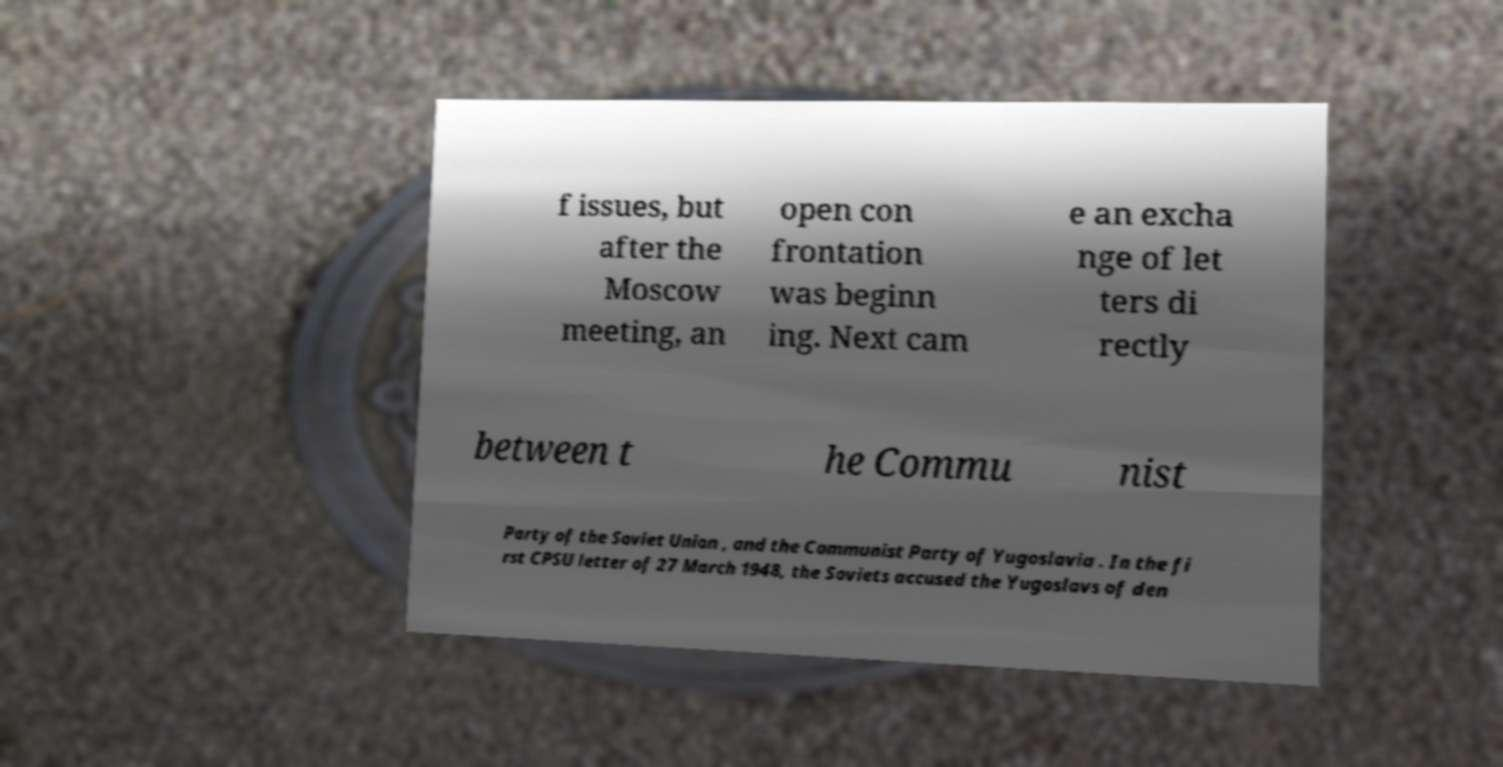I need the written content from this picture converted into text. Can you do that? f issues, but after the Moscow meeting, an open con frontation was beginn ing. Next cam e an excha nge of let ters di rectly between t he Commu nist Party of the Soviet Union , and the Communist Party of Yugoslavia . In the fi rst CPSU letter of 27 March 1948, the Soviets accused the Yugoslavs of den 